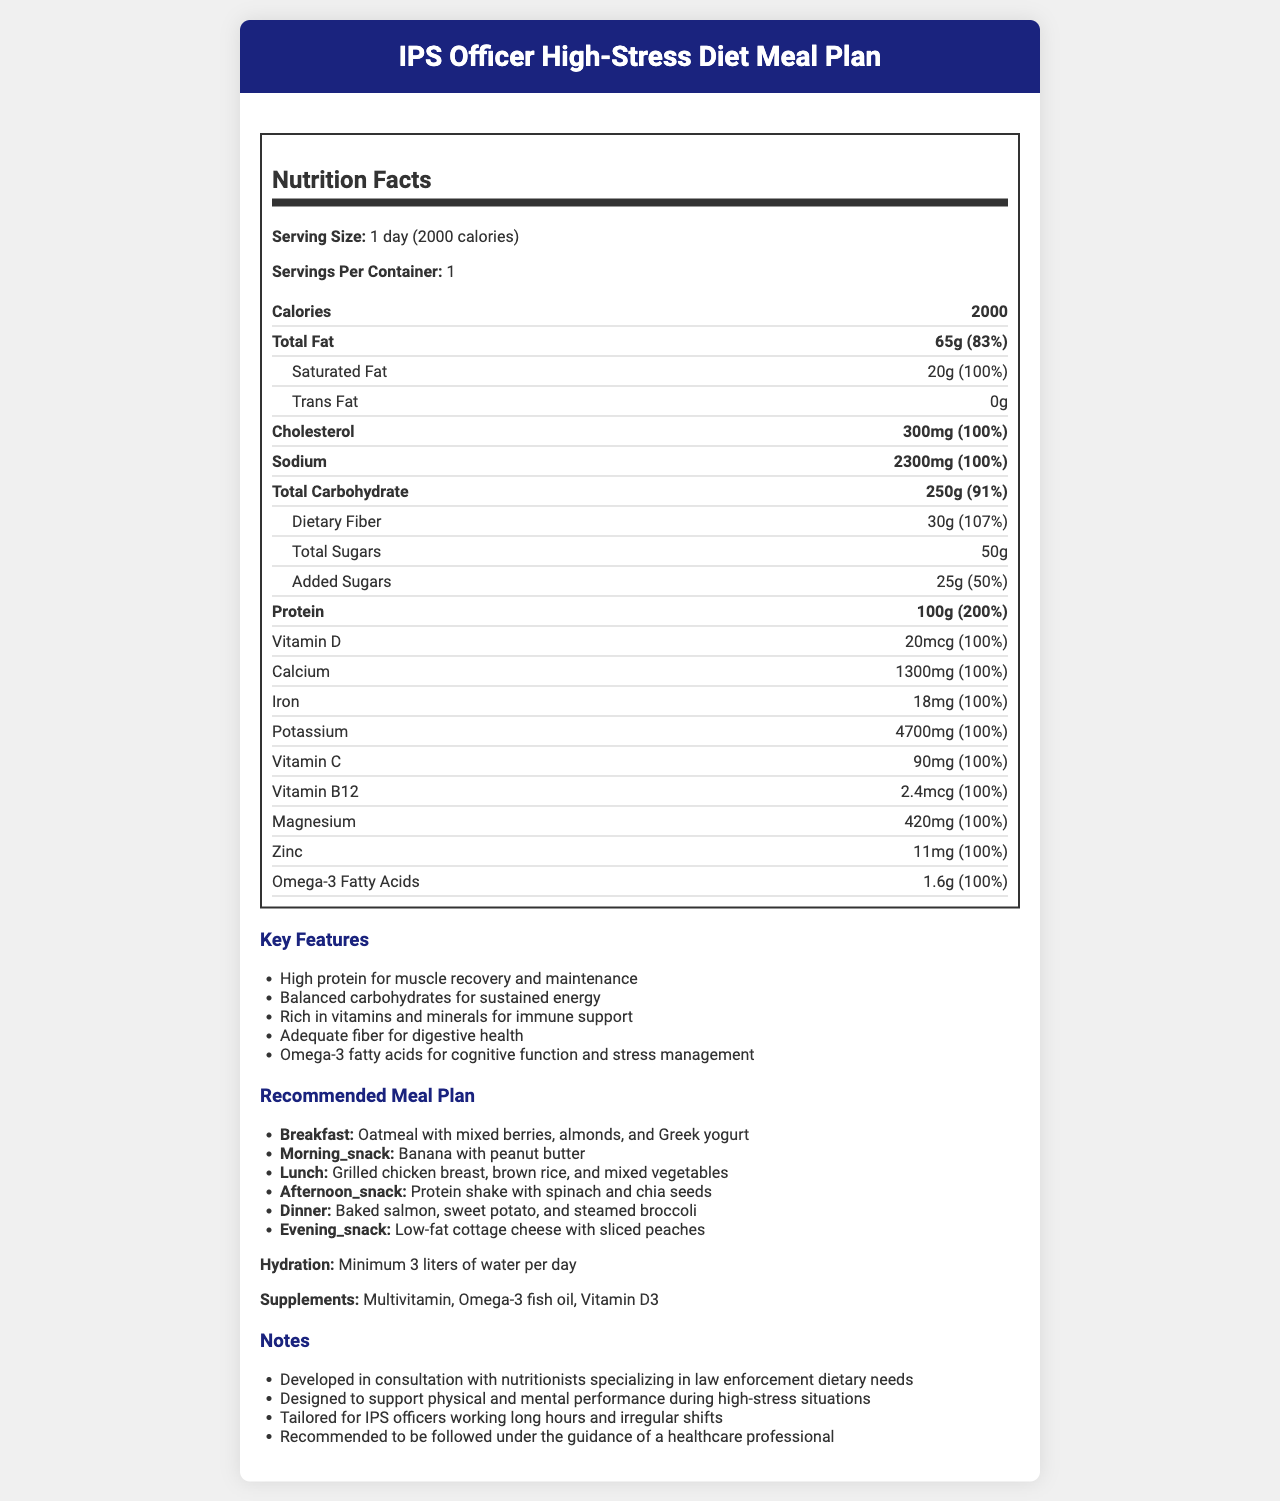what is the product name? The product name is mentioned at the top of the document.
Answer: IPS Officer High-Stress Diet Meal Plan how many calories are in one serving? The document specifies that one serving, which is equivalent to one day, contains 2000 calories.
Answer: 2000 calories what is the total fat content per serving? The total fat content per serving is listed as 65g, which is 83% of the daily value.
Answer: 65g (83%) what are some of the key features of the meal plan? These key features are found under the "Key Features" section of the document.
Answer: High protein for muscle recovery and maintenance, Balanced carbohydrates for sustained energy, Rich in vitamins and minerals for immune support, Adequate fiber for digestive health, Omega-3 fatty acids for cognitive function and stress management how many servings are in one container? The document specifies that there is one serving per container.
Answer: 1 what is the amount of dietary fiber in the meal plan? The dietary fiber amount is 30g, which is 107% of the daily value.
Answer: 30g (107%) what is recommended for breakfast in the meal plan? The meal plan section recommends oatmeal with mixed berries, almonds, and Greek yogurt for breakfast.
Answer: Oatmeal with mixed berries, almonds, and Greek yogurt which vitamin is provided at 100% of the daily value? A. Vitamin A B. Vitamin C C. Vitamin D Vitamin C and other vitamins like D, B12, and so forth are provided at 100% of the daily value, but Vitamin A is not listed.
Answer: B how many grams of protein does the meal plan provide? The document states that the meal plan includes 100g of protein, which is 200% of the daily value.
Answer: 100g (200%) is there any trans fat in this meal plan? The document lists the trans fat content as 0g.
Answer: No how much water is recommended per day according to the meal plan? A. 2 liters B. 3 liters C. 4 liters D. 5 liters The hydration section recommends a minimum of 3 liters of water per day.
Answer: B does the meal plan include a supplement recommendation? The meal plan recommends supplements such as Multivitamin, Omega-3 fish oil, and Vitamin D3.
Answer: Yes what meal is suggested for dinner in the recommended meal plan? The recommended meal plan suggests baked salmon, sweet potato, and steamed broccoli for dinner.
Answer: Baked salmon, sweet potato, and steamed broccoli how much Omega-3 fatty acids are included in the meal plan? The amount of Omega-3 fatty acids included in the meal plan is 1.6g, which is 100% of the daily value.
Answer: 1.6g (100%) what is the primary purpose of this diet plan? The notes section mentions that this diet plan is designed to support physical and mental performance during high-stress situations, targeting IPS officers.
Answer: To support physical and mental performance during high-stress situations for IPS officers describe the entire document or the main idea of the document. This comprehensive answer encompasses the nutritional facts, key features, meal plan, hydration, supplements, and notes regarding the tailored diet for IPS officers.
Answer: The document details the nutritional profile of a specialized diet plan for IPS officers in high-stress positions. It includes detailed nutritional information, key features, a recommended meal plan for each part of the day, hydration and supplement recommendations, and notes about the development and purpose of the diet plan. does the chart provide information on Vitamin A content? The document does not provide any information about the content of Vitamin A.
Answer: No who developed the meal plan? The document mentions it is developed in consultation with nutritionists specializing in law enforcement dietary needs but does not specify who exactly developed it.
Answer: Cannot be determined 